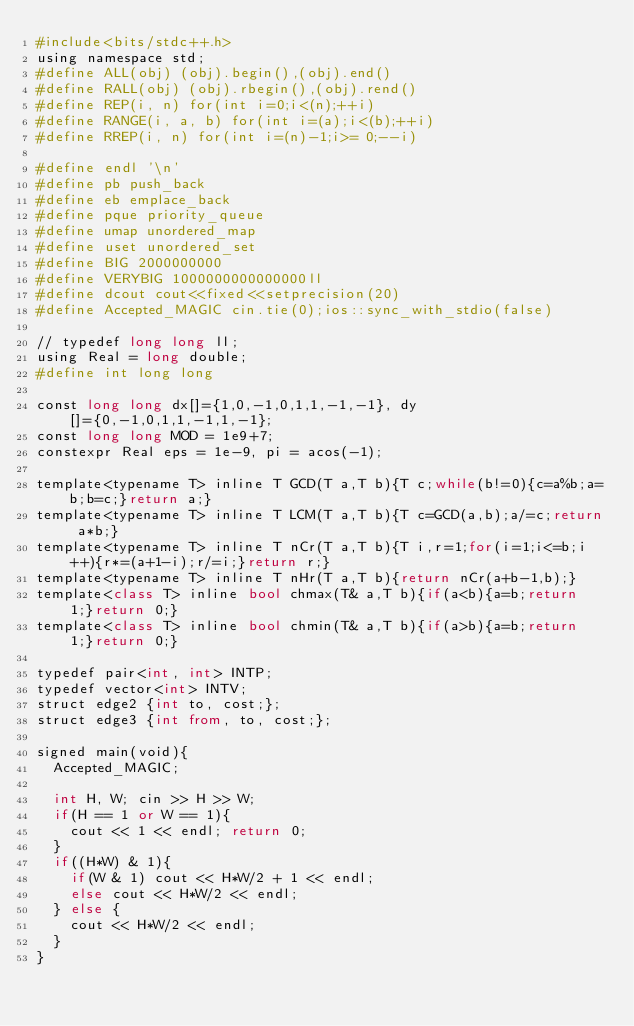Convert code to text. <code><loc_0><loc_0><loc_500><loc_500><_Python_>#include<bits/stdc++.h>
using namespace std;
#define ALL(obj) (obj).begin(),(obj).end()
#define RALL(obj) (obj).rbegin(),(obj).rend()
#define REP(i, n) for(int i=0;i<(n);++i)
#define RANGE(i, a, b) for(int i=(a);i<(b);++i)
#define RREP(i, n) for(int i=(n)-1;i>= 0;--i)

#define endl '\n'
#define pb push_back
#define eb emplace_back
#define pque priority_queue
#define umap unordered_map
#define uset unordered_set
#define BIG 2000000000
#define VERYBIG 1000000000000000ll
#define dcout cout<<fixed<<setprecision(20)
#define Accepted_MAGIC cin.tie(0);ios::sync_with_stdio(false)

// typedef long long ll;
using Real = long double;
#define int long long

const long long dx[]={1,0,-1,0,1,1,-1,-1}, dy[]={0,-1,0,1,1,-1,1,-1};
const long long MOD = 1e9+7;
constexpr Real eps = 1e-9, pi = acos(-1);

template<typename T> inline T GCD(T a,T b){T c;while(b!=0){c=a%b;a=b;b=c;}return a;}
template<typename T> inline T LCM(T a,T b){T c=GCD(a,b);a/=c;return a*b;}
template<typename T> inline T nCr(T a,T b){T i,r=1;for(i=1;i<=b;i++){r*=(a+1-i);r/=i;}return r;}
template<typename T> inline T nHr(T a,T b){return nCr(a+b-1,b);}
template<class T> inline bool chmax(T& a,T b){if(a<b){a=b;return 1;}return 0;}
template<class T> inline bool chmin(T& a,T b){if(a>b){a=b;return 1;}return 0;}

typedef pair<int, int> INTP;
typedef vector<int> INTV;
struct edge2 {int to, cost;};
struct edge3 {int from, to, cost;};

signed main(void){
  Accepted_MAGIC;
  
  int H, W; cin >> H >> W;
  if(H == 1 or W == 1){
    cout << 1 << endl; return 0;
  }
  if((H*W) & 1){
    if(W & 1) cout << H*W/2 + 1 << endl;
    else cout << H*W/2 << endl;
  } else {
    cout << H*W/2 << endl;
  }
}</code> 